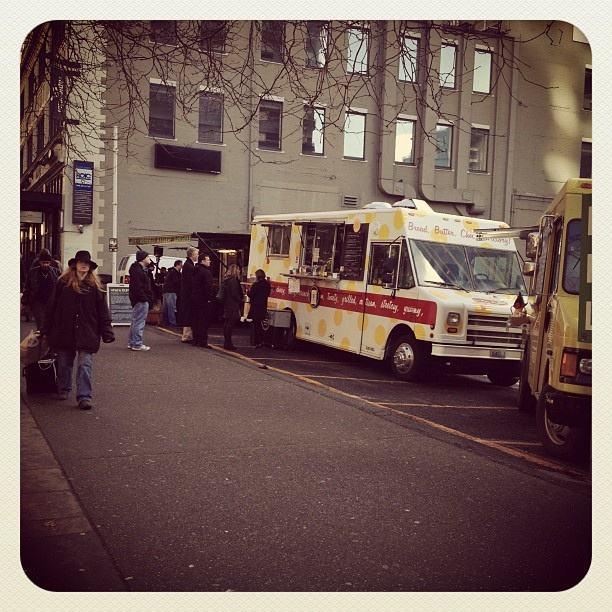Describe the objects in this image and their specific colors. I can see truck in ivory, black, gray, maroon, and tan tones, truck in ivory, black, maroon, and gray tones, people in ivory, black, brown, maroon, and purple tones, people in ivory, black, maroon, gray, and brown tones, and people in ivory, black, brown, and purple tones in this image. 